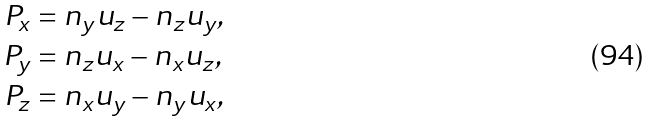<formula> <loc_0><loc_0><loc_500><loc_500>P _ { x } & = n _ { y } u _ { z } - n _ { z } u _ { y } , \\ P _ { y } & = n _ { z } u _ { x } - n _ { x } u _ { z } , \\ P _ { z } & = n _ { x } u _ { y } - n _ { y } u _ { x } ,</formula> 